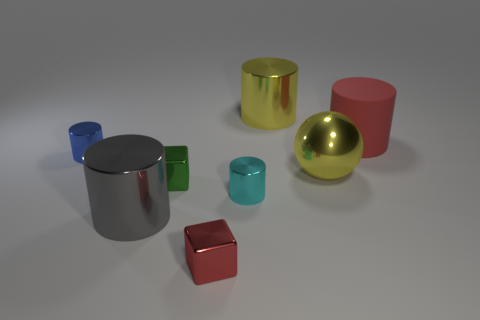Add 2 big balls. How many objects exist? 10 Subtract all metal cylinders. How many cylinders are left? 1 Subtract all balls. How many objects are left? 7 Subtract 1 cubes. How many cubes are left? 1 Subtract all red cylinders. How many cylinders are left? 4 Subtract all purple spheres. How many yellow cubes are left? 0 Subtract all big yellow balls. Subtract all big red rubber objects. How many objects are left? 6 Add 5 metal balls. How many metal balls are left? 6 Add 6 large brown metal cylinders. How many large brown metal cylinders exist? 6 Subtract 1 red cylinders. How many objects are left? 7 